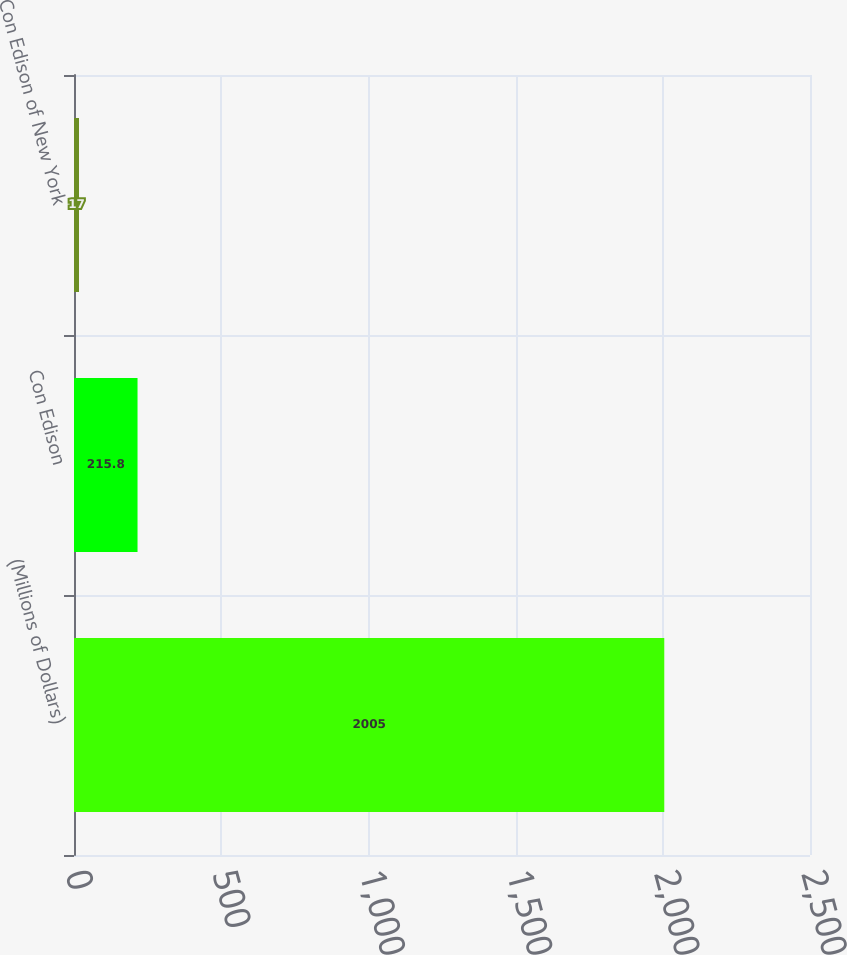Convert chart to OTSL. <chart><loc_0><loc_0><loc_500><loc_500><bar_chart><fcel>(Millions of Dollars)<fcel>Con Edison<fcel>Con Edison of New York<nl><fcel>2005<fcel>215.8<fcel>17<nl></chart> 